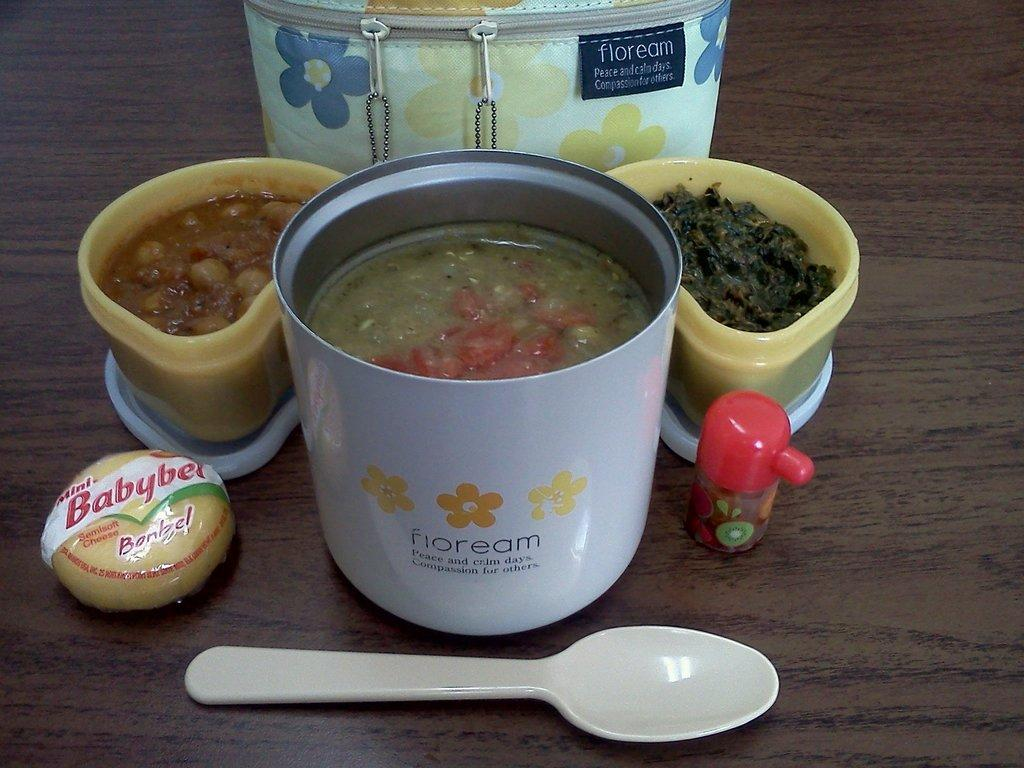What type of table is in the image? There is a wooden table in the image. What is on top of the table? There is a basket and a bowl full of curries on the table. What utensil is present on the table? There is a plastic spoon on the table. What type of minister is sitting next to the basket in the image? There is no minister present in the image. 